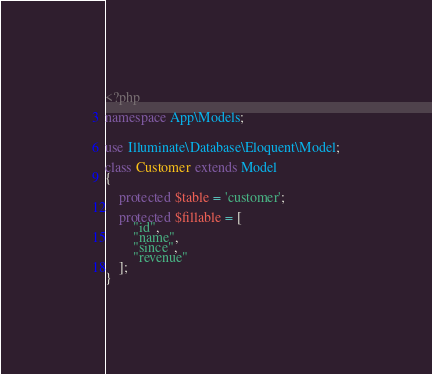<code> <loc_0><loc_0><loc_500><loc_500><_PHP_><?php

namespace App\Models;


use Illuminate\Database\Eloquent\Model;

class Customer extends Model
{

	protected $table = 'customer';

	protected $fillable = [
        "id",
        "name",
        "since",
        "revenue"
    ];
}</code> 